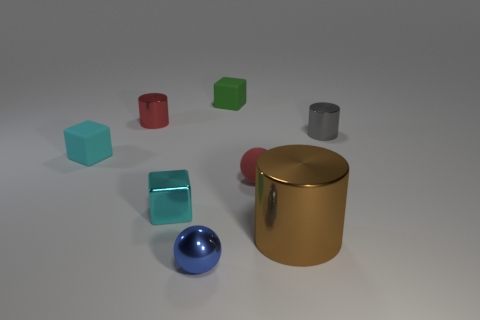Are there any other things that have the same size as the brown shiny thing?
Offer a terse response. No. There is a big metal object that is the same shape as the small gray metal thing; what color is it?
Your answer should be very brief. Brown. How many big things are the same color as the big cylinder?
Keep it short and to the point. 0. How big is the metallic sphere?
Keep it short and to the point. Small. Do the red cylinder and the red matte object have the same size?
Ensure brevity in your answer.  Yes. The small thing that is both behind the cyan rubber cube and on the left side of the small blue metal sphere is what color?
Offer a terse response. Red. How many brown cylinders have the same material as the small green cube?
Give a very brief answer. 0. How many small green metallic spheres are there?
Keep it short and to the point. 0. There is a gray metal thing; is it the same size as the cyan block on the right side of the red shiny cylinder?
Give a very brief answer. Yes. There is a object in front of the metallic cylinder that is in front of the gray metallic object; what is its material?
Provide a short and direct response. Metal. 